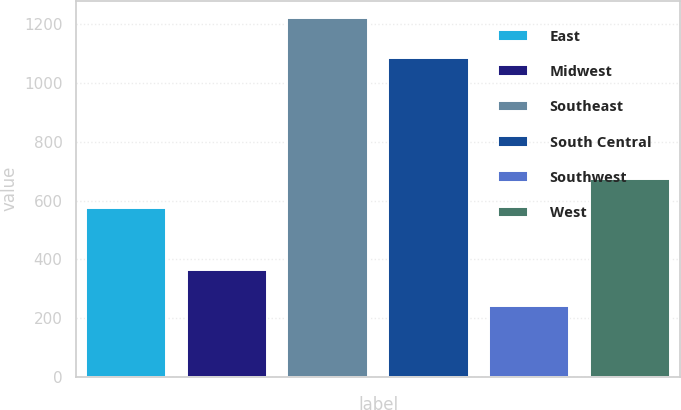Convert chart. <chart><loc_0><loc_0><loc_500><loc_500><bar_chart><fcel>East<fcel>Midwest<fcel>Southeast<fcel>South Central<fcel>Southwest<fcel>West<nl><fcel>576.1<fcel>364.7<fcel>1219.5<fcel>1084<fcel>241.6<fcel>673.89<nl></chart> 